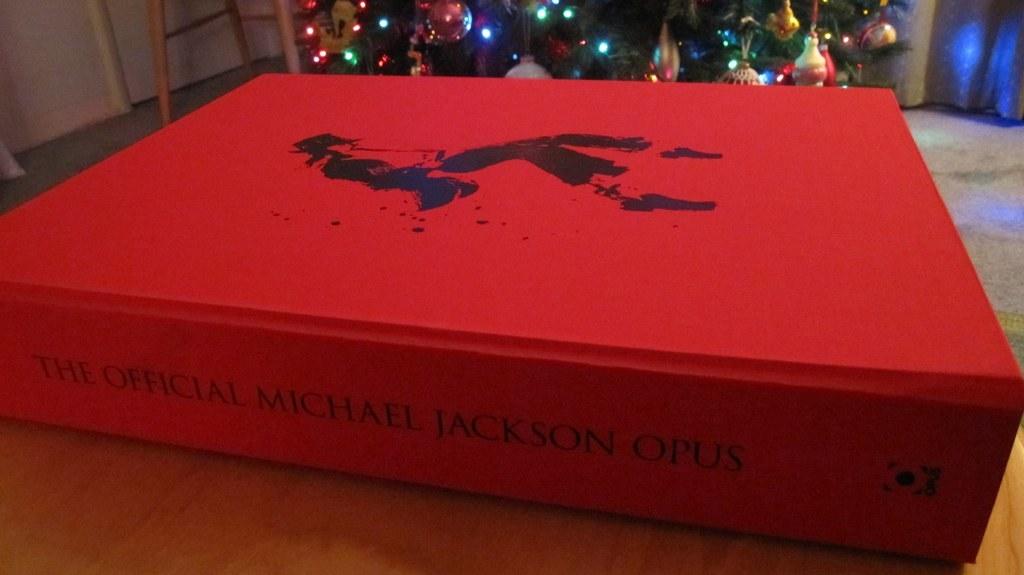The official what?
Offer a terse response. Michael jackson opus. What man name is written on the book?
Your answer should be compact. Michael jackson. 